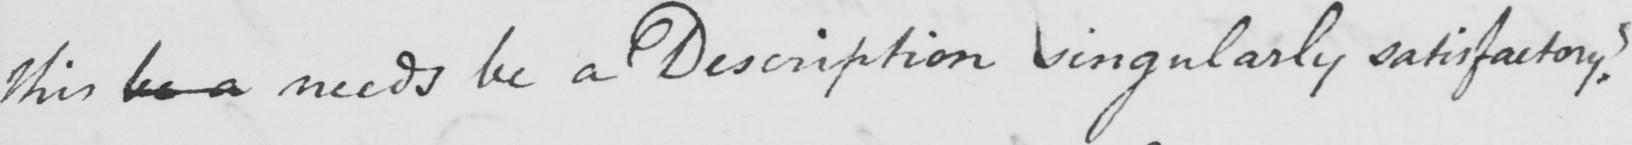Transcribe the text shown in this historical manuscript line. this be a needs be a Description singularly satisfactory ? 